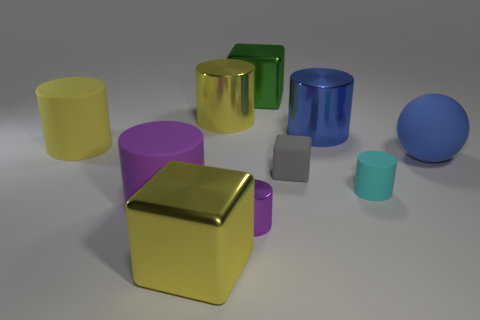Subtract 1 cylinders. How many cylinders are left? 5 Subtract all blue cylinders. How many cylinders are left? 5 Subtract all large yellow rubber cylinders. How many cylinders are left? 5 Subtract all red cylinders. Subtract all green cubes. How many cylinders are left? 6 Subtract all cylinders. How many objects are left? 4 Add 6 small cylinders. How many small cylinders exist? 8 Subtract 0 blue cubes. How many objects are left? 10 Subtract all big blue metallic objects. Subtract all large purple cylinders. How many objects are left? 8 Add 8 big purple matte cylinders. How many big purple matte cylinders are left? 9 